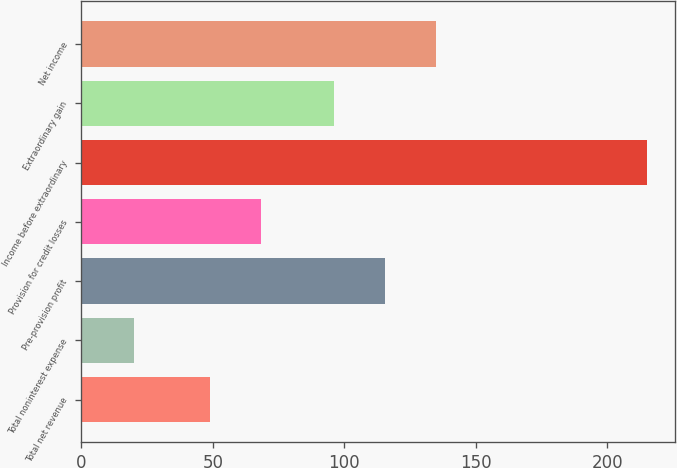Convert chart. <chart><loc_0><loc_0><loc_500><loc_500><bar_chart><fcel>Total net revenue<fcel>Total noninterest expense<fcel>Pre-provision profit<fcel>Provision for credit losses<fcel>Income before extraordinary<fcel>Extraordinary gain<fcel>Net income<nl><fcel>49<fcel>20<fcel>115.5<fcel>68.5<fcel>215<fcel>96<fcel>135<nl></chart> 